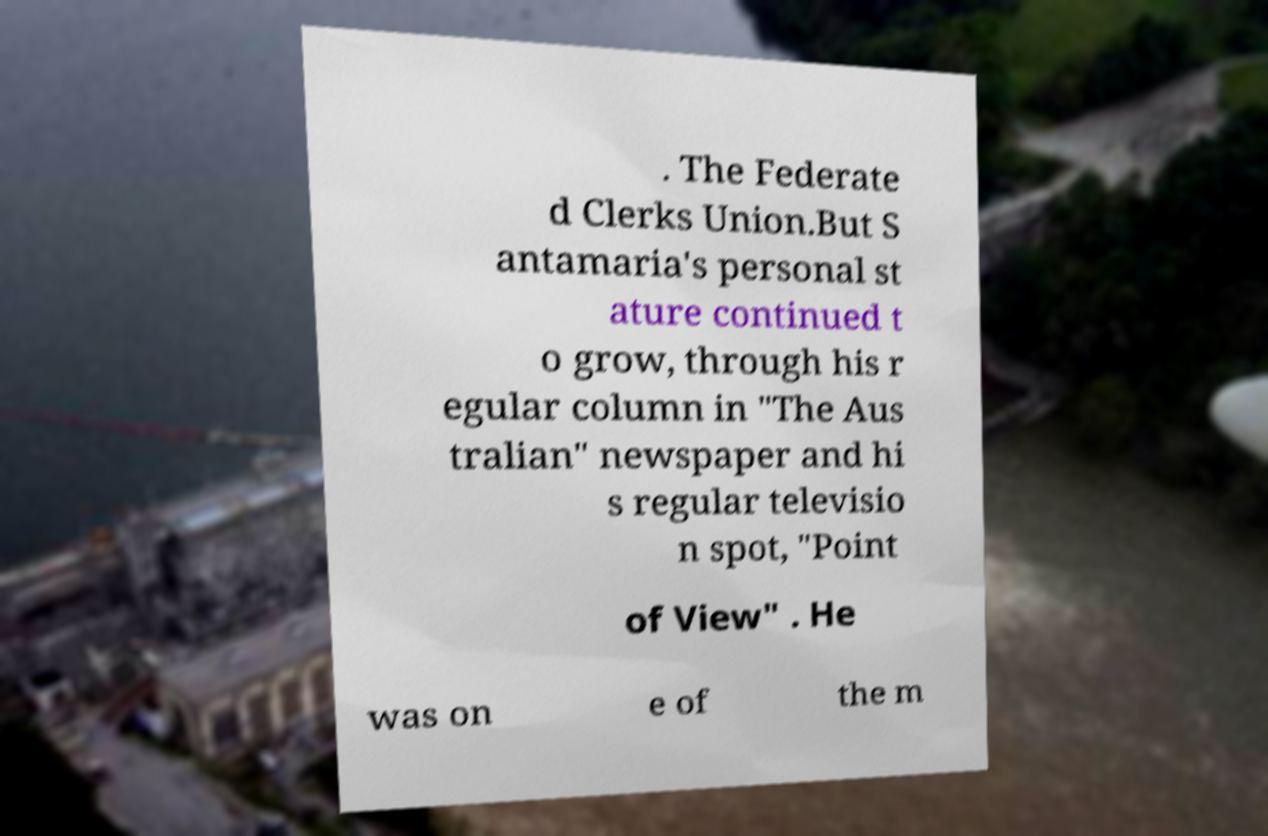Can you accurately transcribe the text from the provided image for me? . The Federate d Clerks Union.But S antamaria's personal st ature continued t o grow, through his r egular column in "The Aus tralian" newspaper and hi s regular televisio n spot, "Point of View" . He was on e of the m 